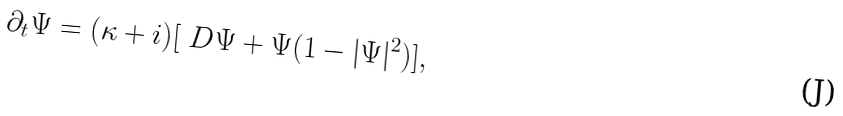Convert formula to latex. <formula><loc_0><loc_0><loc_500><loc_500>\partial _ { t } \Psi = ( \kappa + i ) [ \ D \Psi + \Psi ( 1 - | \Psi | ^ { 2 } ) ] ,</formula> 